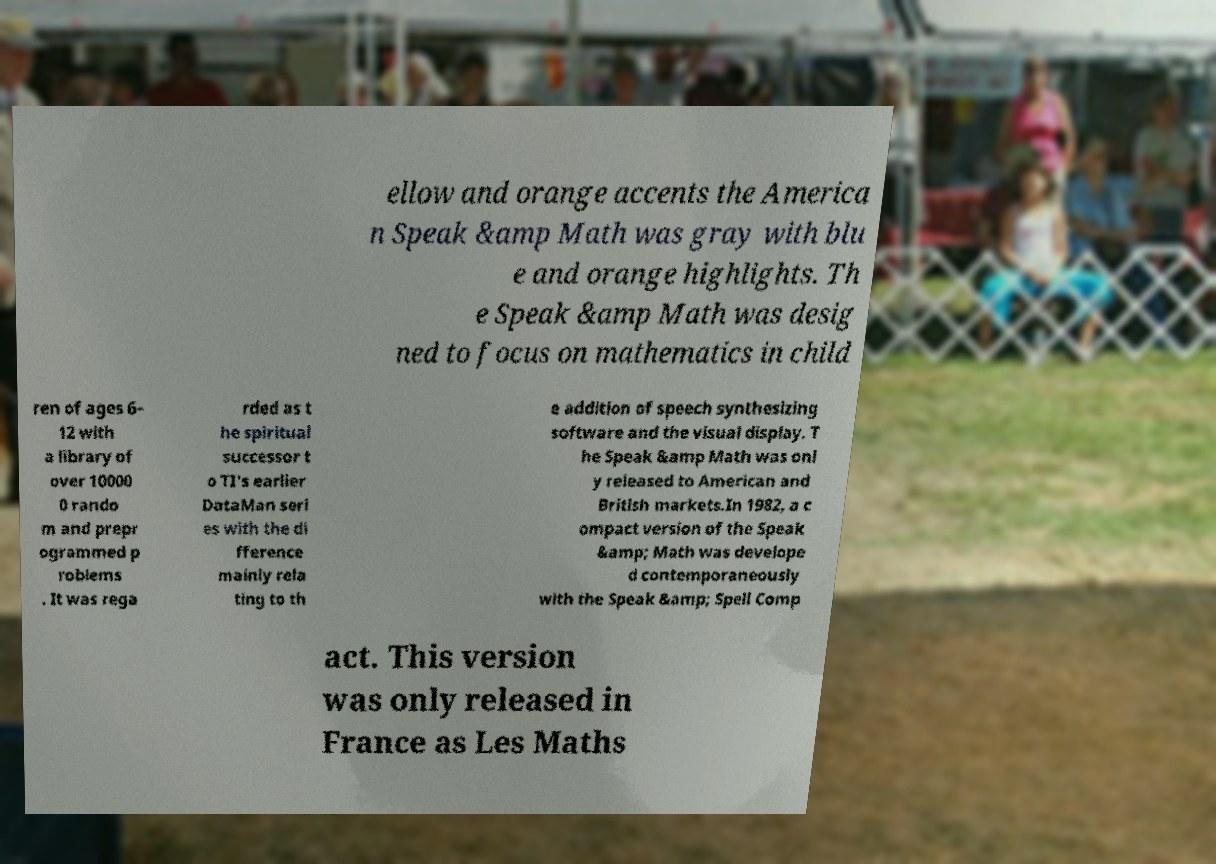Could you extract and type out the text from this image? ellow and orange accents the America n Speak &amp Math was gray with blu e and orange highlights. Th e Speak &amp Math was desig ned to focus on mathematics in child ren of ages 6– 12 with a library of over 10000 0 rando m and prepr ogrammed p roblems . It was rega rded as t he spiritual successor t o TI's earlier DataMan seri es with the di fference mainly rela ting to th e addition of speech synthesizing software and the visual display. T he Speak &amp Math was onl y released to American and British markets.In 1982, a c ompact version of the Speak &amp; Math was develope d contemporaneously with the Speak &amp; Spell Comp act. This version was only released in France as Les Maths 